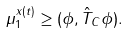<formula> <loc_0><loc_0><loc_500><loc_500>\mu _ { 1 } ^ { x ( { t } ) } \geq ( \phi , \hat { T } _ { C } \phi ) .</formula> 